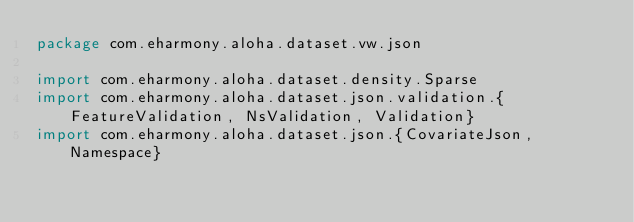<code> <loc_0><loc_0><loc_500><loc_500><_Scala_>package com.eharmony.aloha.dataset.vw.json

import com.eharmony.aloha.dataset.density.Sparse
import com.eharmony.aloha.dataset.json.validation.{FeatureValidation, NsValidation, Validation}
import com.eharmony.aloha.dataset.json.{CovariateJson, Namespace}
</code> 